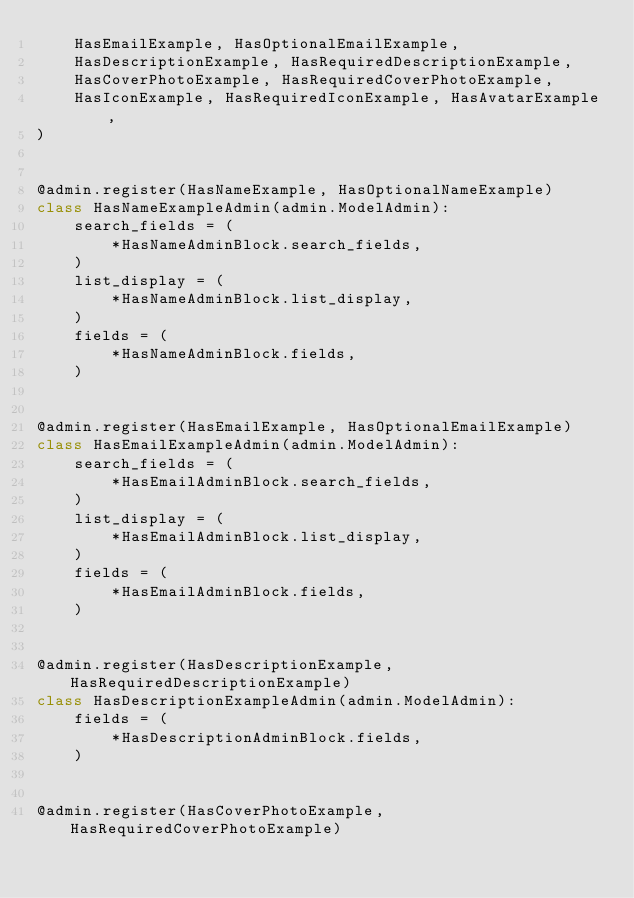<code> <loc_0><loc_0><loc_500><loc_500><_Python_>    HasEmailExample, HasOptionalEmailExample,
    HasDescriptionExample, HasRequiredDescriptionExample,
    HasCoverPhotoExample, HasRequiredCoverPhotoExample,
    HasIconExample, HasRequiredIconExample, HasAvatarExample,
)


@admin.register(HasNameExample, HasOptionalNameExample)
class HasNameExampleAdmin(admin.ModelAdmin):
    search_fields = (
        *HasNameAdminBlock.search_fields,
    )
    list_display = (
        *HasNameAdminBlock.list_display,
    )
    fields = (
        *HasNameAdminBlock.fields,
    )


@admin.register(HasEmailExample, HasOptionalEmailExample)
class HasEmailExampleAdmin(admin.ModelAdmin):
    search_fields = (
        *HasEmailAdminBlock.search_fields,
    )
    list_display = (
        *HasEmailAdminBlock.list_display,
    )
    fields = (
        *HasEmailAdminBlock.fields,
    )


@admin.register(HasDescriptionExample, HasRequiredDescriptionExample)
class HasDescriptionExampleAdmin(admin.ModelAdmin):
    fields = (
        *HasDescriptionAdminBlock.fields,
    )


@admin.register(HasCoverPhotoExample, HasRequiredCoverPhotoExample)</code> 